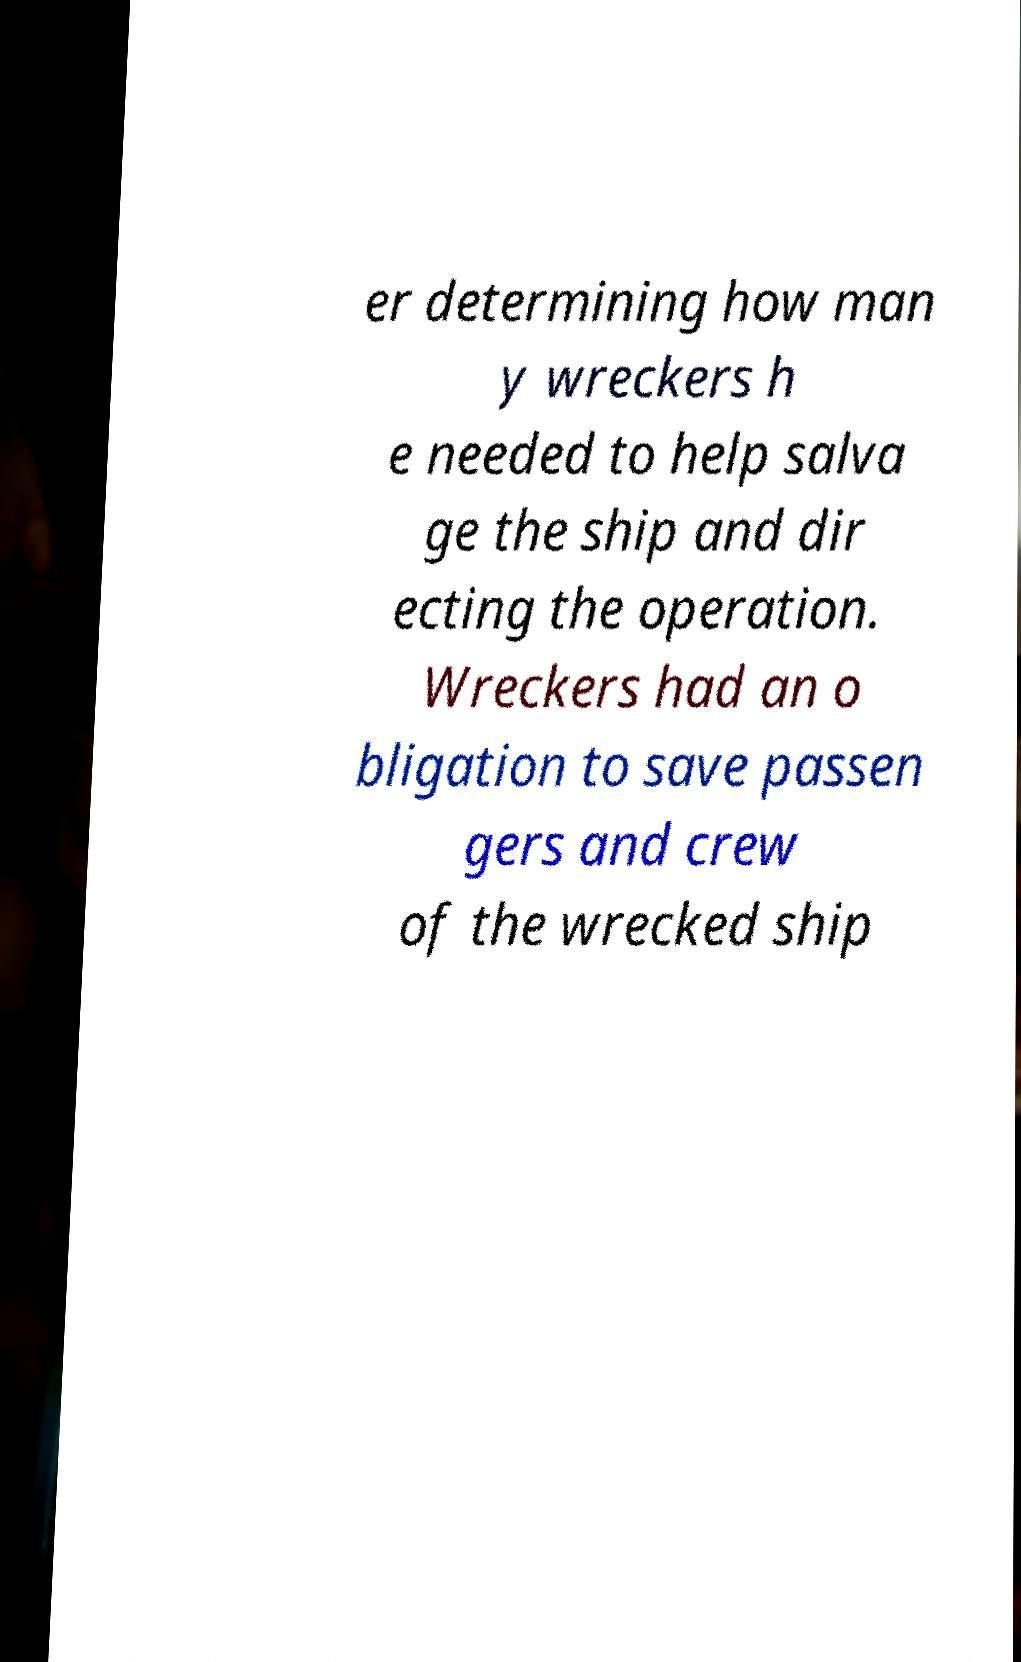Can you read and provide the text displayed in the image?This photo seems to have some interesting text. Can you extract and type it out for me? er determining how man y wreckers h e needed to help salva ge the ship and dir ecting the operation. Wreckers had an o bligation to save passen gers and crew of the wrecked ship 